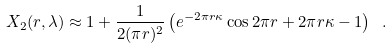Convert formula to latex. <formula><loc_0><loc_0><loc_500><loc_500>X _ { 2 } ( r , \lambda ) \approx 1 + \frac { 1 } { 2 ( \pi r ) ^ { 2 } } \left ( e ^ { - 2 \pi r \kappa } \cos 2 \pi r + 2 \pi r \kappa - 1 \right ) \ .</formula> 